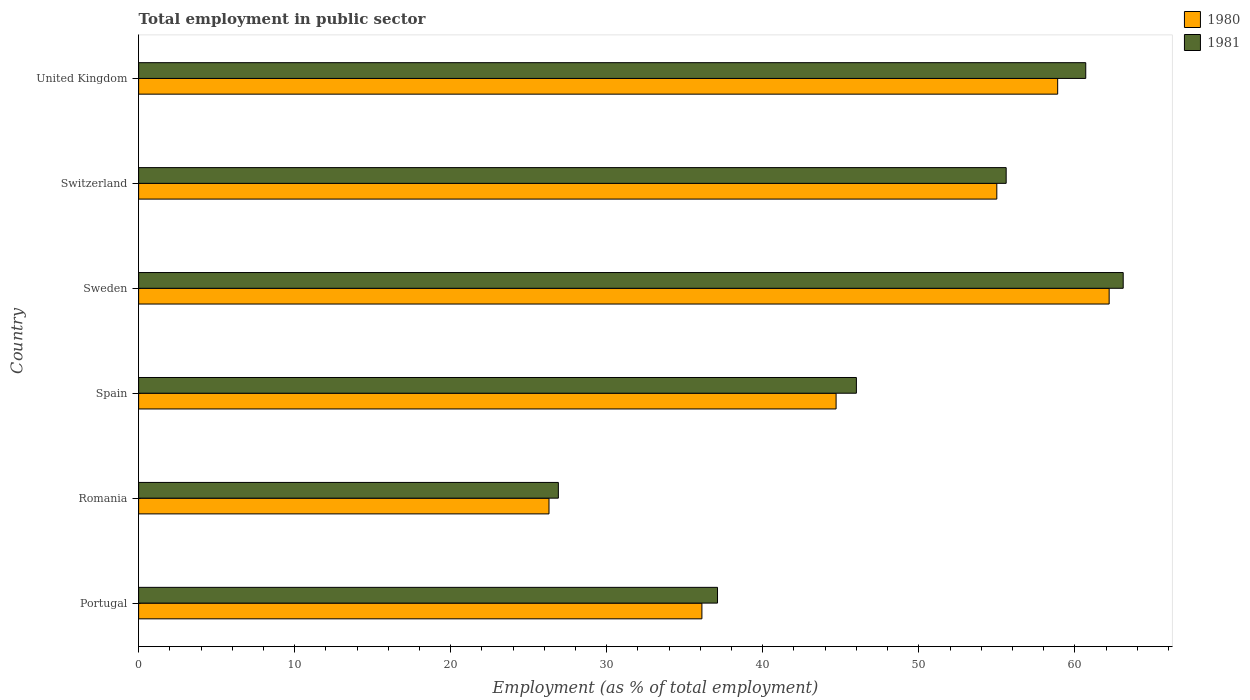How many groups of bars are there?
Offer a terse response. 6. Are the number of bars per tick equal to the number of legend labels?
Your answer should be compact. Yes. Are the number of bars on each tick of the Y-axis equal?
Offer a terse response. Yes. How many bars are there on the 5th tick from the top?
Make the answer very short. 2. What is the label of the 2nd group of bars from the top?
Keep it short and to the point. Switzerland. In how many cases, is the number of bars for a given country not equal to the number of legend labels?
Your answer should be very brief. 0. What is the employment in public sector in 1980 in Romania?
Give a very brief answer. 26.3. Across all countries, what is the maximum employment in public sector in 1980?
Your answer should be very brief. 62.2. Across all countries, what is the minimum employment in public sector in 1981?
Make the answer very short. 26.9. In which country was the employment in public sector in 1980 maximum?
Your response must be concise. Sweden. In which country was the employment in public sector in 1980 minimum?
Offer a very short reply. Romania. What is the total employment in public sector in 1980 in the graph?
Provide a short and direct response. 283.2. What is the difference between the employment in public sector in 1980 in Portugal and that in Sweden?
Offer a very short reply. -26.1. What is the difference between the employment in public sector in 1980 in United Kingdom and the employment in public sector in 1981 in Sweden?
Offer a very short reply. -4.2. What is the average employment in public sector in 1980 per country?
Give a very brief answer. 47.2. What is the difference between the employment in public sector in 1981 and employment in public sector in 1980 in Spain?
Keep it short and to the point. 1.3. In how many countries, is the employment in public sector in 1980 greater than 10 %?
Offer a terse response. 6. What is the ratio of the employment in public sector in 1981 in Portugal to that in Spain?
Ensure brevity in your answer.  0.81. Is the employment in public sector in 1981 in Spain less than that in United Kingdom?
Your response must be concise. Yes. Is the difference between the employment in public sector in 1981 in Romania and Spain greater than the difference between the employment in public sector in 1980 in Romania and Spain?
Your response must be concise. No. What is the difference between the highest and the second highest employment in public sector in 1981?
Your response must be concise. 2.4. What is the difference between the highest and the lowest employment in public sector in 1981?
Your answer should be compact. 36.2. In how many countries, is the employment in public sector in 1980 greater than the average employment in public sector in 1980 taken over all countries?
Ensure brevity in your answer.  3. Is the sum of the employment in public sector in 1981 in Switzerland and United Kingdom greater than the maximum employment in public sector in 1980 across all countries?
Give a very brief answer. Yes. Are all the bars in the graph horizontal?
Your answer should be compact. Yes. Are the values on the major ticks of X-axis written in scientific E-notation?
Provide a short and direct response. No. Where does the legend appear in the graph?
Provide a short and direct response. Top right. What is the title of the graph?
Keep it short and to the point. Total employment in public sector. What is the label or title of the X-axis?
Offer a very short reply. Employment (as % of total employment). What is the Employment (as % of total employment) of 1980 in Portugal?
Your answer should be compact. 36.1. What is the Employment (as % of total employment) in 1981 in Portugal?
Your answer should be compact. 37.1. What is the Employment (as % of total employment) of 1980 in Romania?
Give a very brief answer. 26.3. What is the Employment (as % of total employment) of 1981 in Romania?
Your answer should be compact. 26.9. What is the Employment (as % of total employment) of 1980 in Spain?
Offer a terse response. 44.7. What is the Employment (as % of total employment) in 1981 in Spain?
Keep it short and to the point. 46. What is the Employment (as % of total employment) in 1980 in Sweden?
Your response must be concise. 62.2. What is the Employment (as % of total employment) in 1981 in Sweden?
Make the answer very short. 63.1. What is the Employment (as % of total employment) of 1981 in Switzerland?
Provide a short and direct response. 55.6. What is the Employment (as % of total employment) in 1980 in United Kingdom?
Keep it short and to the point. 58.9. What is the Employment (as % of total employment) in 1981 in United Kingdom?
Your answer should be very brief. 60.7. Across all countries, what is the maximum Employment (as % of total employment) in 1980?
Your answer should be very brief. 62.2. Across all countries, what is the maximum Employment (as % of total employment) in 1981?
Provide a succinct answer. 63.1. Across all countries, what is the minimum Employment (as % of total employment) of 1980?
Your answer should be compact. 26.3. Across all countries, what is the minimum Employment (as % of total employment) of 1981?
Your answer should be very brief. 26.9. What is the total Employment (as % of total employment) in 1980 in the graph?
Give a very brief answer. 283.2. What is the total Employment (as % of total employment) of 1981 in the graph?
Ensure brevity in your answer.  289.4. What is the difference between the Employment (as % of total employment) of 1980 in Portugal and that in Sweden?
Your answer should be compact. -26.1. What is the difference between the Employment (as % of total employment) in 1980 in Portugal and that in Switzerland?
Offer a very short reply. -18.9. What is the difference between the Employment (as % of total employment) in 1981 in Portugal and that in Switzerland?
Your answer should be compact. -18.5. What is the difference between the Employment (as % of total employment) of 1980 in Portugal and that in United Kingdom?
Your answer should be very brief. -22.8. What is the difference between the Employment (as % of total employment) in 1981 in Portugal and that in United Kingdom?
Make the answer very short. -23.6. What is the difference between the Employment (as % of total employment) of 1980 in Romania and that in Spain?
Your response must be concise. -18.4. What is the difference between the Employment (as % of total employment) in 1981 in Romania and that in Spain?
Your answer should be very brief. -19.1. What is the difference between the Employment (as % of total employment) in 1980 in Romania and that in Sweden?
Ensure brevity in your answer.  -35.9. What is the difference between the Employment (as % of total employment) of 1981 in Romania and that in Sweden?
Provide a short and direct response. -36.2. What is the difference between the Employment (as % of total employment) of 1980 in Romania and that in Switzerland?
Your answer should be very brief. -28.7. What is the difference between the Employment (as % of total employment) in 1981 in Romania and that in Switzerland?
Ensure brevity in your answer.  -28.7. What is the difference between the Employment (as % of total employment) of 1980 in Romania and that in United Kingdom?
Keep it short and to the point. -32.6. What is the difference between the Employment (as % of total employment) in 1981 in Romania and that in United Kingdom?
Your answer should be very brief. -33.8. What is the difference between the Employment (as % of total employment) of 1980 in Spain and that in Sweden?
Your answer should be compact. -17.5. What is the difference between the Employment (as % of total employment) of 1981 in Spain and that in Sweden?
Your response must be concise. -17.1. What is the difference between the Employment (as % of total employment) in 1980 in Spain and that in Switzerland?
Make the answer very short. -10.3. What is the difference between the Employment (as % of total employment) of 1981 in Spain and that in Switzerland?
Offer a very short reply. -9.6. What is the difference between the Employment (as % of total employment) in 1980 in Spain and that in United Kingdom?
Offer a terse response. -14.2. What is the difference between the Employment (as % of total employment) of 1981 in Spain and that in United Kingdom?
Keep it short and to the point. -14.7. What is the difference between the Employment (as % of total employment) in 1981 in Sweden and that in Switzerland?
Provide a succinct answer. 7.5. What is the difference between the Employment (as % of total employment) of 1980 in Sweden and that in United Kingdom?
Make the answer very short. 3.3. What is the difference between the Employment (as % of total employment) in 1981 in Sweden and that in United Kingdom?
Offer a terse response. 2.4. What is the difference between the Employment (as % of total employment) of 1981 in Switzerland and that in United Kingdom?
Offer a terse response. -5.1. What is the difference between the Employment (as % of total employment) in 1980 in Portugal and the Employment (as % of total employment) in 1981 in Romania?
Provide a succinct answer. 9.2. What is the difference between the Employment (as % of total employment) of 1980 in Portugal and the Employment (as % of total employment) of 1981 in Switzerland?
Give a very brief answer. -19.5. What is the difference between the Employment (as % of total employment) of 1980 in Portugal and the Employment (as % of total employment) of 1981 in United Kingdom?
Make the answer very short. -24.6. What is the difference between the Employment (as % of total employment) of 1980 in Romania and the Employment (as % of total employment) of 1981 in Spain?
Provide a succinct answer. -19.7. What is the difference between the Employment (as % of total employment) of 1980 in Romania and the Employment (as % of total employment) of 1981 in Sweden?
Offer a terse response. -36.8. What is the difference between the Employment (as % of total employment) in 1980 in Romania and the Employment (as % of total employment) in 1981 in Switzerland?
Offer a very short reply. -29.3. What is the difference between the Employment (as % of total employment) of 1980 in Romania and the Employment (as % of total employment) of 1981 in United Kingdom?
Make the answer very short. -34.4. What is the difference between the Employment (as % of total employment) in 1980 in Spain and the Employment (as % of total employment) in 1981 in Sweden?
Provide a succinct answer. -18.4. What is the difference between the Employment (as % of total employment) in 1980 in Spain and the Employment (as % of total employment) in 1981 in United Kingdom?
Your answer should be compact. -16. What is the difference between the Employment (as % of total employment) of 1980 in Sweden and the Employment (as % of total employment) of 1981 in Switzerland?
Provide a succinct answer. 6.6. What is the difference between the Employment (as % of total employment) of 1980 in Sweden and the Employment (as % of total employment) of 1981 in United Kingdom?
Your answer should be very brief. 1.5. What is the difference between the Employment (as % of total employment) in 1980 in Switzerland and the Employment (as % of total employment) in 1981 in United Kingdom?
Offer a very short reply. -5.7. What is the average Employment (as % of total employment) of 1980 per country?
Your answer should be compact. 47.2. What is the average Employment (as % of total employment) in 1981 per country?
Your answer should be compact. 48.23. What is the difference between the Employment (as % of total employment) of 1980 and Employment (as % of total employment) of 1981 in Portugal?
Your response must be concise. -1. What is the difference between the Employment (as % of total employment) in 1980 and Employment (as % of total employment) in 1981 in Sweden?
Provide a short and direct response. -0.9. What is the difference between the Employment (as % of total employment) of 1980 and Employment (as % of total employment) of 1981 in Switzerland?
Offer a terse response. -0.6. What is the ratio of the Employment (as % of total employment) of 1980 in Portugal to that in Romania?
Provide a succinct answer. 1.37. What is the ratio of the Employment (as % of total employment) in 1981 in Portugal to that in Romania?
Offer a terse response. 1.38. What is the ratio of the Employment (as % of total employment) in 1980 in Portugal to that in Spain?
Ensure brevity in your answer.  0.81. What is the ratio of the Employment (as % of total employment) of 1981 in Portugal to that in Spain?
Make the answer very short. 0.81. What is the ratio of the Employment (as % of total employment) of 1980 in Portugal to that in Sweden?
Provide a short and direct response. 0.58. What is the ratio of the Employment (as % of total employment) of 1981 in Portugal to that in Sweden?
Ensure brevity in your answer.  0.59. What is the ratio of the Employment (as % of total employment) of 1980 in Portugal to that in Switzerland?
Provide a succinct answer. 0.66. What is the ratio of the Employment (as % of total employment) in 1981 in Portugal to that in Switzerland?
Ensure brevity in your answer.  0.67. What is the ratio of the Employment (as % of total employment) of 1980 in Portugal to that in United Kingdom?
Your answer should be compact. 0.61. What is the ratio of the Employment (as % of total employment) of 1981 in Portugal to that in United Kingdom?
Ensure brevity in your answer.  0.61. What is the ratio of the Employment (as % of total employment) of 1980 in Romania to that in Spain?
Provide a succinct answer. 0.59. What is the ratio of the Employment (as % of total employment) in 1981 in Romania to that in Spain?
Offer a terse response. 0.58. What is the ratio of the Employment (as % of total employment) of 1980 in Romania to that in Sweden?
Provide a succinct answer. 0.42. What is the ratio of the Employment (as % of total employment) in 1981 in Romania to that in Sweden?
Keep it short and to the point. 0.43. What is the ratio of the Employment (as % of total employment) in 1980 in Romania to that in Switzerland?
Make the answer very short. 0.48. What is the ratio of the Employment (as % of total employment) of 1981 in Romania to that in Switzerland?
Your response must be concise. 0.48. What is the ratio of the Employment (as % of total employment) in 1980 in Romania to that in United Kingdom?
Offer a terse response. 0.45. What is the ratio of the Employment (as % of total employment) in 1981 in Romania to that in United Kingdom?
Offer a very short reply. 0.44. What is the ratio of the Employment (as % of total employment) of 1980 in Spain to that in Sweden?
Your response must be concise. 0.72. What is the ratio of the Employment (as % of total employment) of 1981 in Spain to that in Sweden?
Offer a very short reply. 0.73. What is the ratio of the Employment (as % of total employment) in 1980 in Spain to that in Switzerland?
Your response must be concise. 0.81. What is the ratio of the Employment (as % of total employment) of 1981 in Spain to that in Switzerland?
Give a very brief answer. 0.83. What is the ratio of the Employment (as % of total employment) in 1980 in Spain to that in United Kingdom?
Give a very brief answer. 0.76. What is the ratio of the Employment (as % of total employment) in 1981 in Spain to that in United Kingdom?
Ensure brevity in your answer.  0.76. What is the ratio of the Employment (as % of total employment) in 1980 in Sweden to that in Switzerland?
Keep it short and to the point. 1.13. What is the ratio of the Employment (as % of total employment) of 1981 in Sweden to that in Switzerland?
Offer a very short reply. 1.13. What is the ratio of the Employment (as % of total employment) of 1980 in Sweden to that in United Kingdom?
Your answer should be very brief. 1.06. What is the ratio of the Employment (as % of total employment) of 1981 in Sweden to that in United Kingdom?
Your response must be concise. 1.04. What is the ratio of the Employment (as % of total employment) in 1980 in Switzerland to that in United Kingdom?
Keep it short and to the point. 0.93. What is the ratio of the Employment (as % of total employment) in 1981 in Switzerland to that in United Kingdom?
Give a very brief answer. 0.92. What is the difference between the highest and the lowest Employment (as % of total employment) in 1980?
Your response must be concise. 35.9. What is the difference between the highest and the lowest Employment (as % of total employment) of 1981?
Keep it short and to the point. 36.2. 